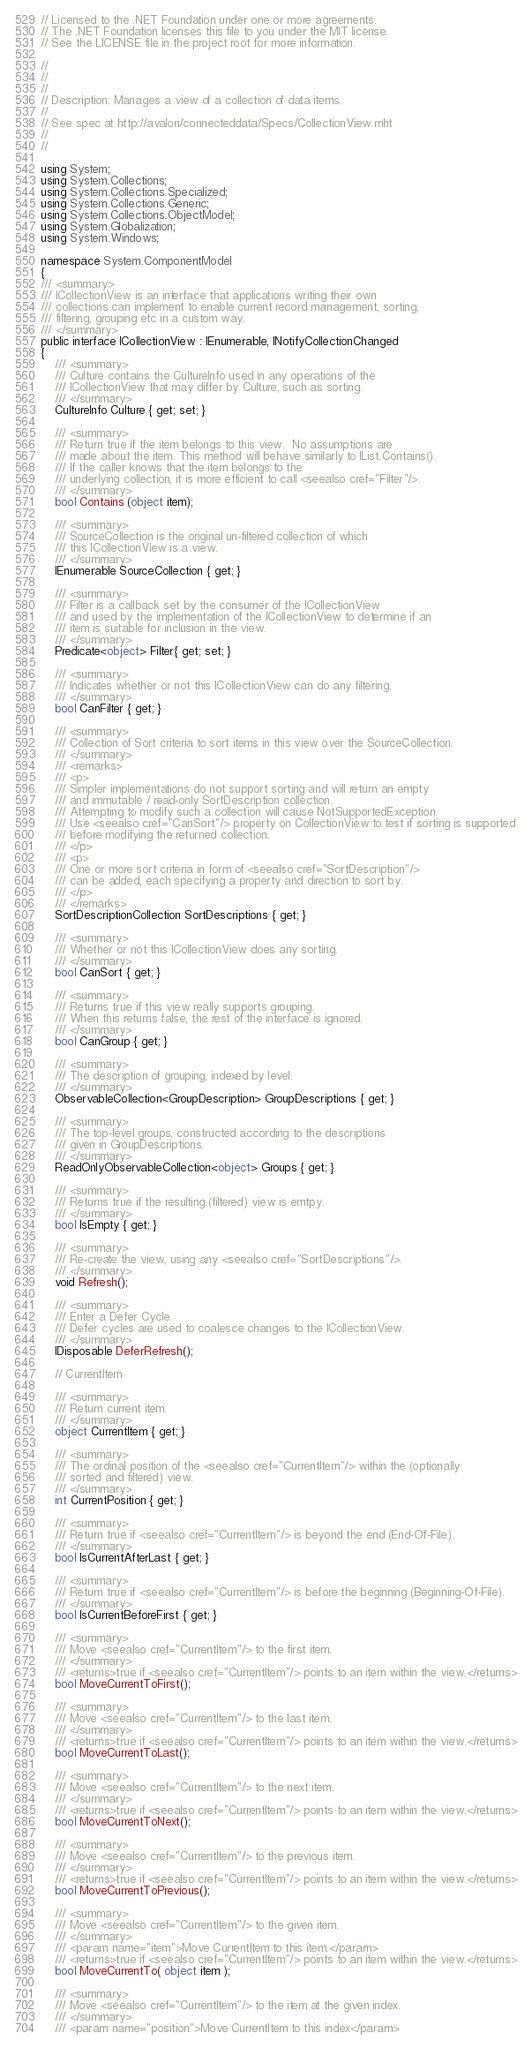Convert code to text. <code><loc_0><loc_0><loc_500><loc_500><_C#_>// Licensed to the .NET Foundation under one or more agreements.
// The .NET Foundation licenses this file to you under the MIT license.
// See the LICENSE file in the project root for more information.

//
//
//
// Description: Manages a view of a collection of data items.
//
// See spec at http://avalon/connecteddata/Specs/CollectionView.mht
//
//

using System;
using System.Collections;
using System.Collections.Specialized;
using System.Collections.Generic;
using System.Collections.ObjectModel;
using System.Globalization;
using System.Windows;

namespace System.ComponentModel
{
/// <summary>
/// ICollectionView is an interface that applications writing their own
/// collections can implement to enable current record management, sorting,
/// filtering, grouping etc in a custom way.
/// </summary>
public interface ICollectionView : IEnumerable, INotifyCollectionChanged
{
    /// <summary>
    /// Culture contains the CultureInfo used in any operations of the
    /// ICollectionView that may differ by Culture, such as sorting.
    /// </summary>
    CultureInfo Culture { get; set; }

    /// <summary>
    /// Return true if the item belongs to this view.  No assumptions are
    /// made about the item. This method will behave similarly to IList.Contains().
    /// If the caller knows that the item belongs to the
    /// underlying collection, it is more efficient to call <seealso cref="Filter"/>.
    /// </summary>
    bool Contains (object item);

    /// <summary>
    /// SourceCollection is the original un-filtered collection of which
    /// this ICollectionView is a view.
    /// </summary>
    IEnumerable SourceCollection { get; }

    /// <summary>
    /// Filter is a callback set by the consumer of the ICollectionView
    /// and used by the implementation of the ICollectionView to determine if an
    /// item is suitable for inclusion in the view.
    /// </summary>
    Predicate<object> Filter{ get; set; }

    /// <summary>
    /// Indicates whether or not this ICollectionView can do any filtering.
    /// </summary>
    bool CanFilter { get; }

    /// <summary>
    /// Collection of Sort criteria to sort items in this view over the SourceCollection.
    /// </summary>
    /// <remarks>
    /// <p>
    /// Simpler implementations do not support sorting and will return an empty
    /// and immutable / read-only SortDescription collection.
    /// Attempting to modify such a collection will cause NotSupportedException.
    /// Use <seealso cref="CanSort"/> property on CollectionView to test if sorting is supported
    /// before modifying the returned collection.
    /// </p>
    /// <p>
    /// One or more sort criteria in form of <seealso cref="SortDescription"/>
    /// can be added, each specifying a property and direction to sort by.
    /// </p>
    /// </remarks>
    SortDescriptionCollection SortDescriptions { get; }

    /// <summary>
    /// Whether or not this ICollectionView does any sorting.
    /// </summary>
    bool CanSort { get; }

    /// <summary>
    /// Returns true if this view really supports grouping.
    /// When this returns false, the rest of the interface is ignored.
    /// </summary>
    bool CanGroup { get; }

    /// <summary>
    /// The description of grouping, indexed by level.
    /// </summary>
    ObservableCollection<GroupDescription> GroupDescriptions { get; }

    /// <summary>
    /// The top-level groups, constructed according to the descriptions
    /// given in GroupDescriptions.
    /// </summary>
    ReadOnlyObservableCollection<object> Groups { get; }

    /// <summary>
    /// Returns true if the resulting (filtered) view is emtpy.
    /// </summary>
    bool IsEmpty { get; }

    /// <summary>
    /// Re-create the view, using any <seealso cref="SortDescriptions"/>.
    /// </summary>
    void Refresh();

    /// <summary>
    /// Enter a Defer Cycle.
    /// Defer cycles are used to coalesce changes to the ICollectionView.
    /// </summary>
    IDisposable DeferRefresh();

    // CurrentItem

    /// <summary>
    /// Return current item.
    /// </summary>
    object CurrentItem { get; }

    /// <summary>
    /// The ordinal position of the <seealso cref="CurrentItem"/> within the (optionally
    /// sorted and filtered) view.
    /// </summary>
    int CurrentPosition { get; }

    /// <summary>
    /// Return true if <seealso cref="CurrentItem"/> is beyond the end (End-Of-File).
    /// </summary>
    bool IsCurrentAfterLast { get; }

    /// <summary>
    /// Return true if <seealso cref="CurrentItem"/> is before the beginning (Beginning-Of-File).
    /// </summary>
    bool IsCurrentBeforeFirst { get; }

    /// <summary>
    /// Move <seealso cref="CurrentItem"/> to the first item.
    /// </summary>
    /// <returns>true if <seealso cref="CurrentItem"/> points to an item within the view.</returns>
    bool MoveCurrentToFirst();

    /// <summary>
    /// Move <seealso cref="CurrentItem"/> to the last item.
    /// </summary>
    /// <returns>true if <seealso cref="CurrentItem"/> points to an item within the view.</returns>
    bool MoveCurrentToLast();

    /// <summary>
    /// Move <seealso cref="CurrentItem"/> to the next item.
    /// </summary>
    /// <returns>true if <seealso cref="CurrentItem"/> points to an item within the view.</returns>
    bool MoveCurrentToNext();

    /// <summary>
    /// Move <seealso cref="CurrentItem"/> to the previous item.
    /// </summary>
    /// <returns>true if <seealso cref="CurrentItem"/> points to an item within the view.</returns>
    bool MoveCurrentToPrevious();

    /// <summary>
    /// Move <seealso cref="CurrentItem"/> to the given item.
    /// </summary>
    /// <param name="item">Move CurrentItem to this item.</param>
    /// <returns>true if <seealso cref="CurrentItem"/> points to an item within the view.</returns>
    bool MoveCurrentTo( object item );

    /// <summary>
    /// Move <seealso cref="CurrentItem"/> to the item at the given index.
    /// </summary>
    /// <param name="position">Move CurrentItem to this index</param></code> 